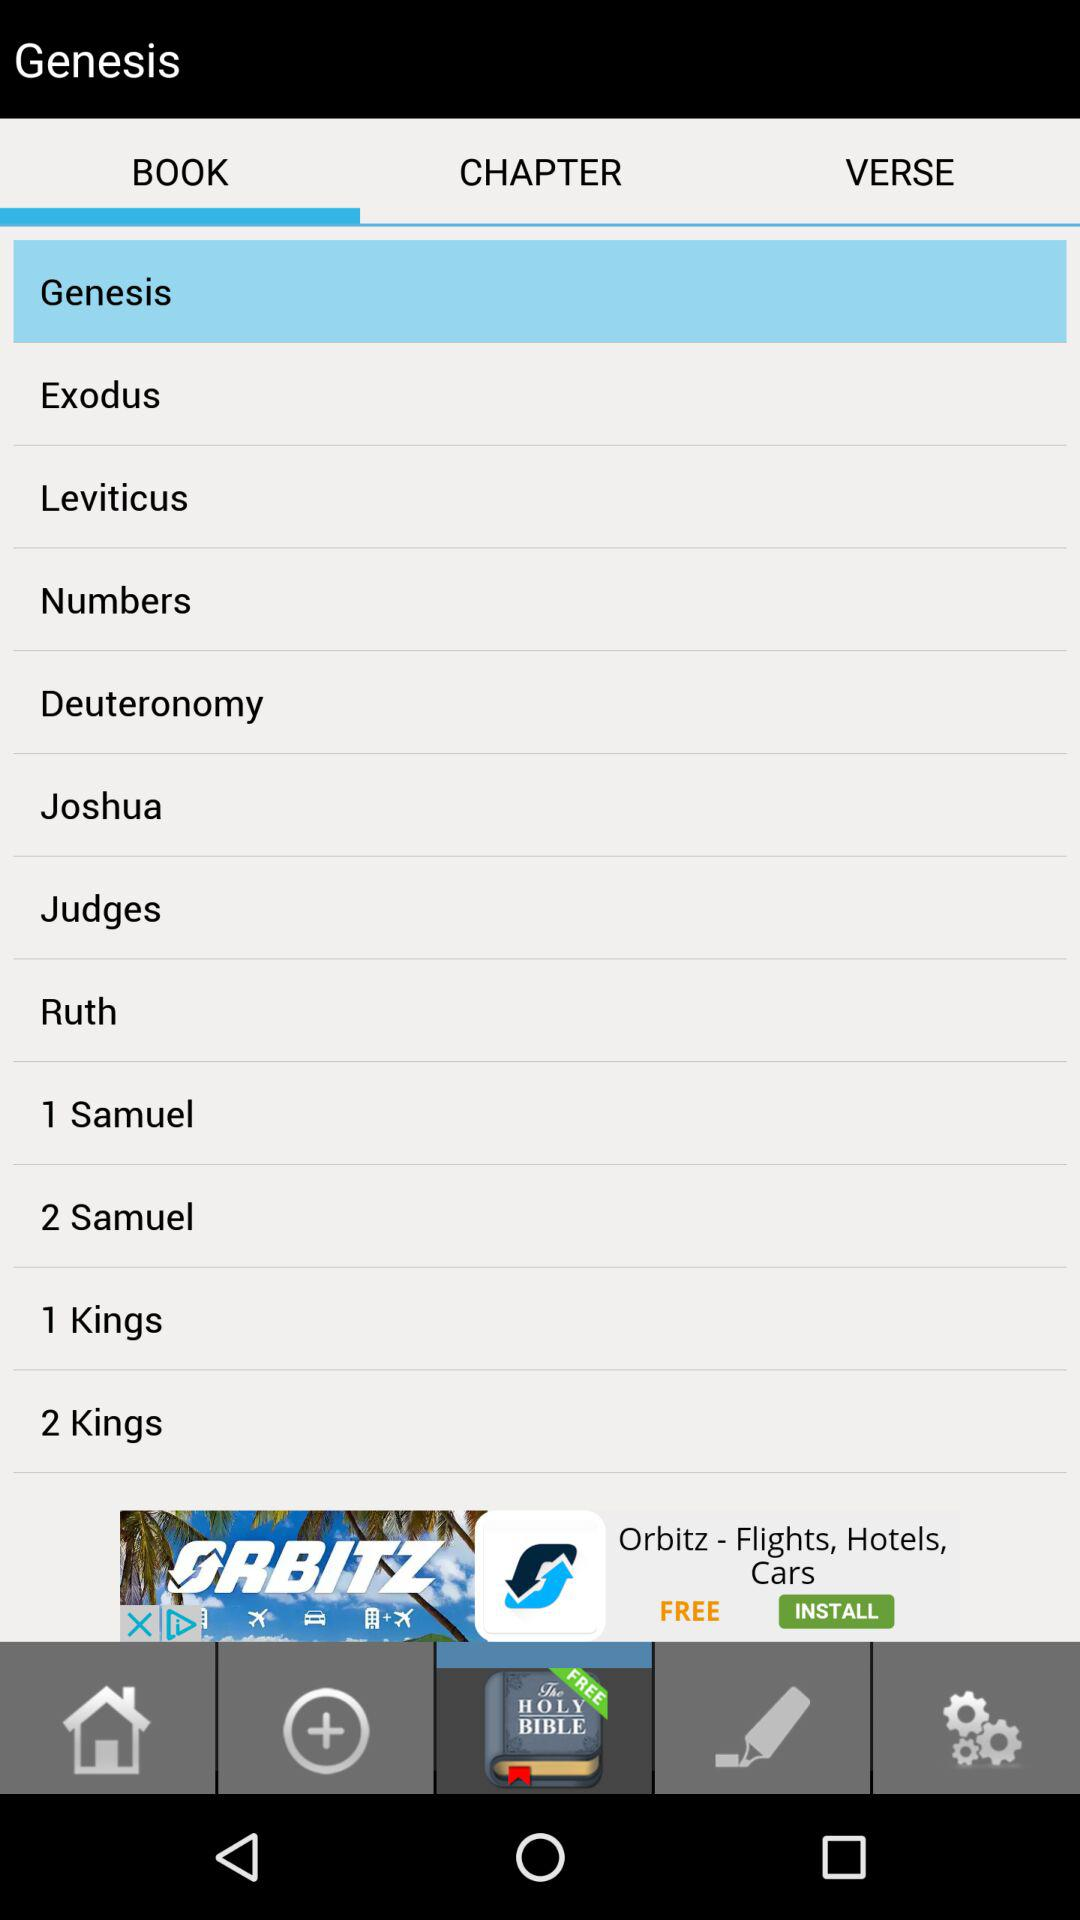What option is selected? The selected option is Genesis. 